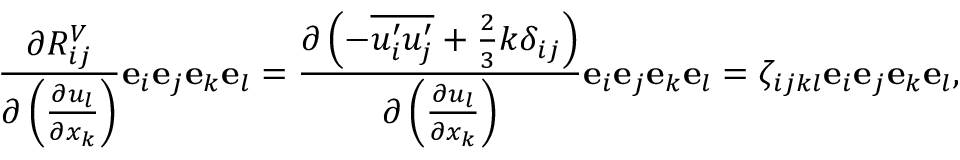Convert formula to latex. <formula><loc_0><loc_0><loc_500><loc_500>\frac { \partial R _ { i j } ^ { V } } { \partial \left ( \frac { \partial u _ { l } } { \partial x _ { k } } \right ) } e _ { i } e _ { j } e _ { k } e _ { l } = \frac { \partial \left ( - \overline { { u _ { i } ^ { \prime } u _ { j } ^ { \prime } } } + \frac { 2 } { 3 } k \delta _ { i j } \right ) } { \partial \left ( \frac { \partial u _ { l } } { \partial x _ { k } } \right ) } e _ { i } e _ { j } e _ { k } e _ { l } = \zeta _ { i j k l } e _ { i } e _ { j } e _ { k } e _ { l } ,</formula> 